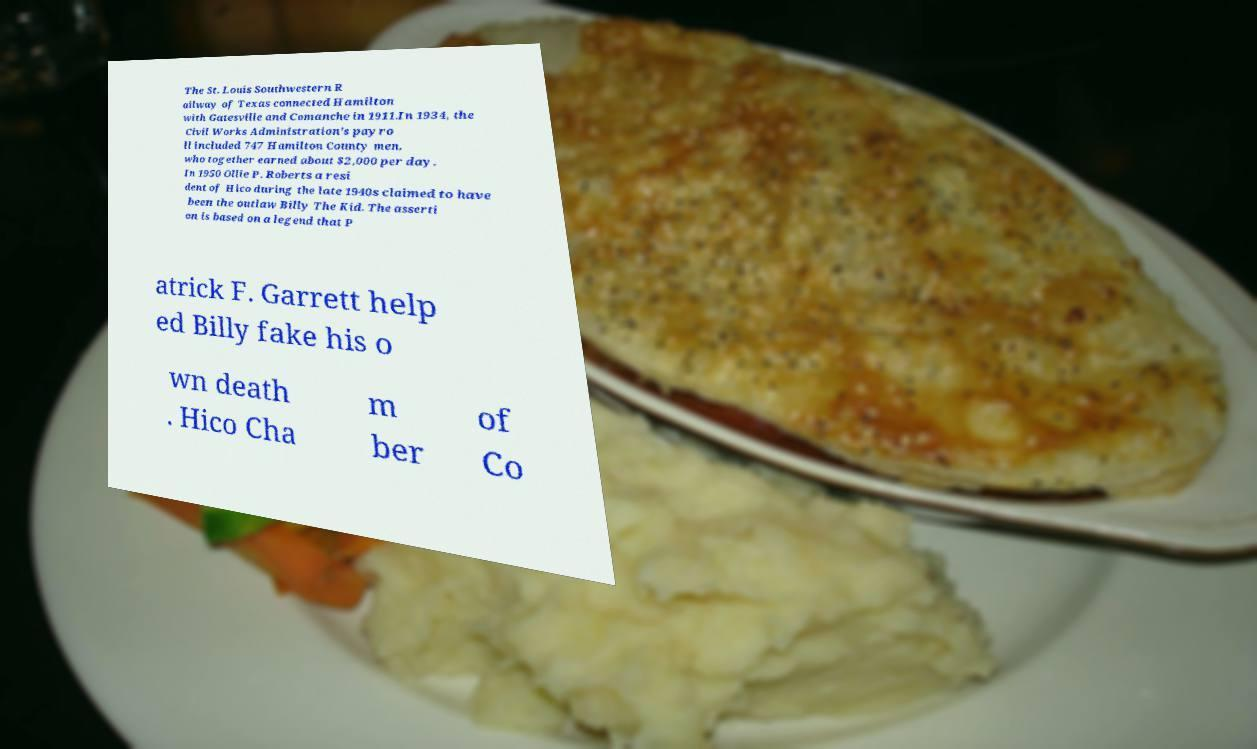There's text embedded in this image that I need extracted. Can you transcribe it verbatim? The St. Louis Southwestern R ailway of Texas connected Hamilton with Gatesville and Comanche in 1911.In 1934, the Civil Works Administration's payro ll included 747 Hamilton County men, who together earned about $2,000 per day. In 1950 Ollie P. Roberts a resi dent of Hico during the late 1940s claimed to have been the outlaw Billy The Kid. The asserti on is based on a legend that P atrick F. Garrett help ed Billy fake his o wn death . Hico Cha m ber of Co 